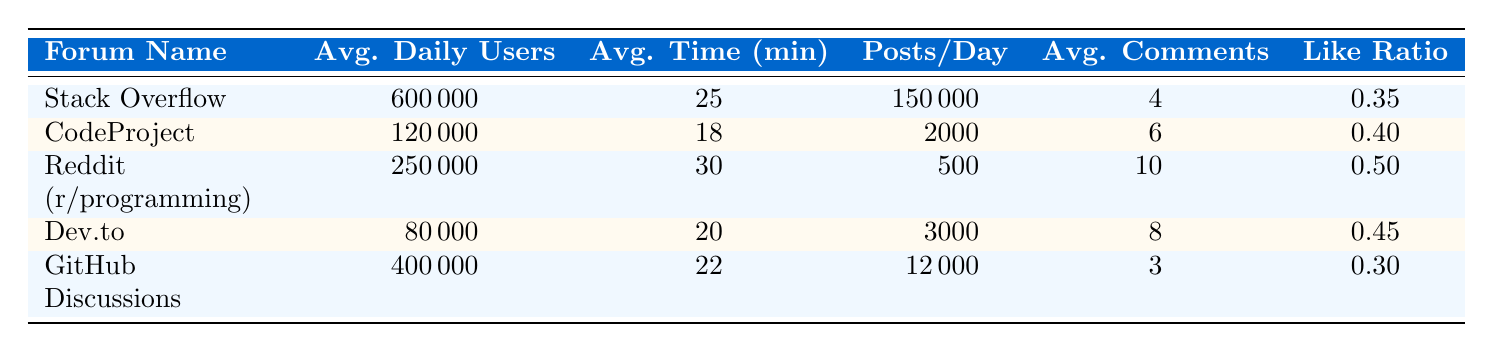What is the average daily user count for Stack Overflow? The table directly lists Stack Overflow's average daily users as 600000 under the corresponding column for average daily users.
Answer: 600000 Which forum has the highest like ratio? By examining the like ratio column, Reddit (r/programming) shows a like ratio of 0.50, which is higher than all other forums listed.
Answer: Reddit (r/programming) Calculate the average time spent per user across all forums. First, we sum the average times: 25 (Stack Overflow) + 18 (CodeProject) + 30 (Reddit) + 20 (Dev.to) + 22 (GitHub Discussions) = 125. There are 5 forums, so we divide by 5: 125/5 = 25.
Answer: 25 Does GitHub Discussions have more average daily users than Dev.to? From the table, GitHub Discussions has 400000 average daily users, while Dev.to has 80000, indicating that GitHub Discussions has more users.
Answer: Yes What is the total number of posts made per day across all forums? To find the total posts per day, we sum the posts per day for all forums: 150000 (Stack Overflow) + 2000 (CodeProject) + 500 (Reddit) + 3000 (Dev.to) + 12000 (GitHub Discussions) = 167502.
Answer: 167502 Is the average time spent per user on CodeProject higher than on Dev.to? The average time spent per user on CodeProject is 18 minutes, while on Dev.to it is 20 minutes; thus, CodeProject's average time spent is lower.
Answer: No Which forum has the lowest number of average daily users? By inspecting the average daily users column, Dev.to has the lowest count of 80000 users, which is less than all other forums.
Answer: Dev.to How many more comments per post does Reddit (r/programming) receive compared to GitHub Discussions? Reddit (r/programming) has an average of 10 comments per post, while GitHub Discussions has 3 comments. The difference is 10 - 3 = 7 comments.
Answer: 7 